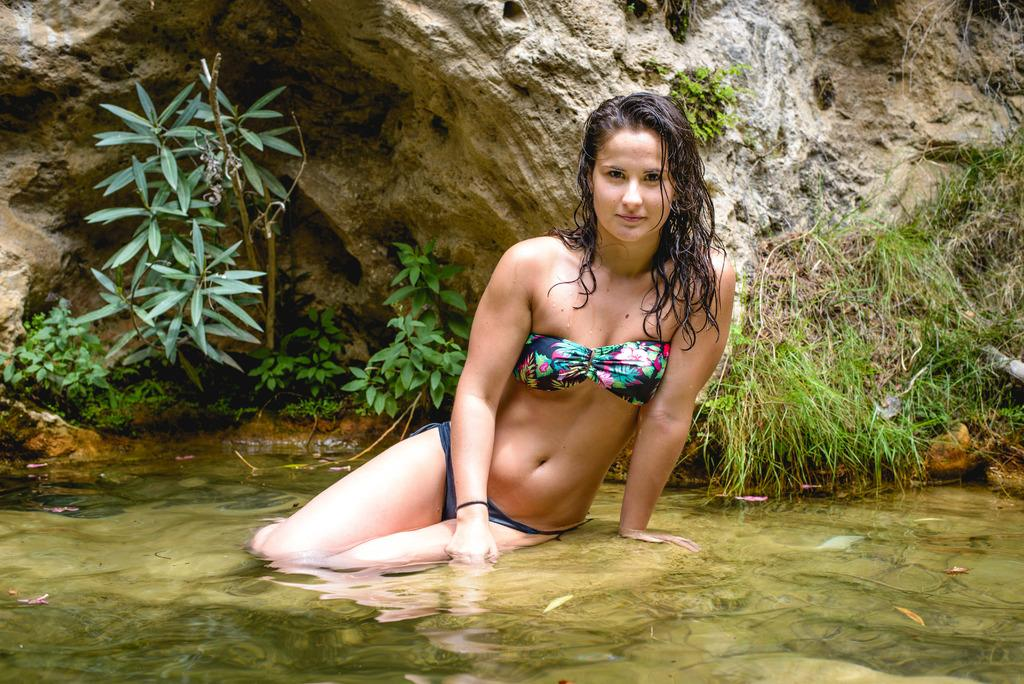What is the woman in the image doing? There is a woman in the water in the image. What type of vegetation can be seen in the image? Plants and grass are visible in the image. What geological feature is visible in the image? There is a rock visible in the image. What type of business is being conducted on the island in the image? There is no island present in the image, and therefore no business being conducted. What scientific theory can be observed in action in the image? There is no scientific theory being demonstrated in the image. 